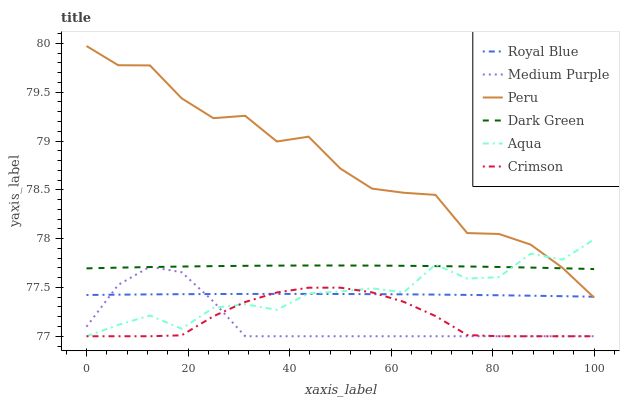Does Medium Purple have the minimum area under the curve?
Answer yes or no. Yes. Does Peru have the maximum area under the curve?
Answer yes or no. Yes. Does Royal Blue have the minimum area under the curve?
Answer yes or no. No. Does Royal Blue have the maximum area under the curve?
Answer yes or no. No. Is Royal Blue the smoothest?
Answer yes or no. Yes. Is Peru the roughest?
Answer yes or no. Yes. Is Medium Purple the smoothest?
Answer yes or no. No. Is Medium Purple the roughest?
Answer yes or no. No. Does Aqua have the lowest value?
Answer yes or no. Yes. Does Royal Blue have the lowest value?
Answer yes or no. No. Does Peru have the highest value?
Answer yes or no. Yes. Does Medium Purple have the highest value?
Answer yes or no. No. Is Crimson less than Peru?
Answer yes or no. Yes. Is Peru greater than Crimson?
Answer yes or no. Yes. Does Peru intersect Royal Blue?
Answer yes or no. Yes. Is Peru less than Royal Blue?
Answer yes or no. No. Is Peru greater than Royal Blue?
Answer yes or no. No. Does Crimson intersect Peru?
Answer yes or no. No. 